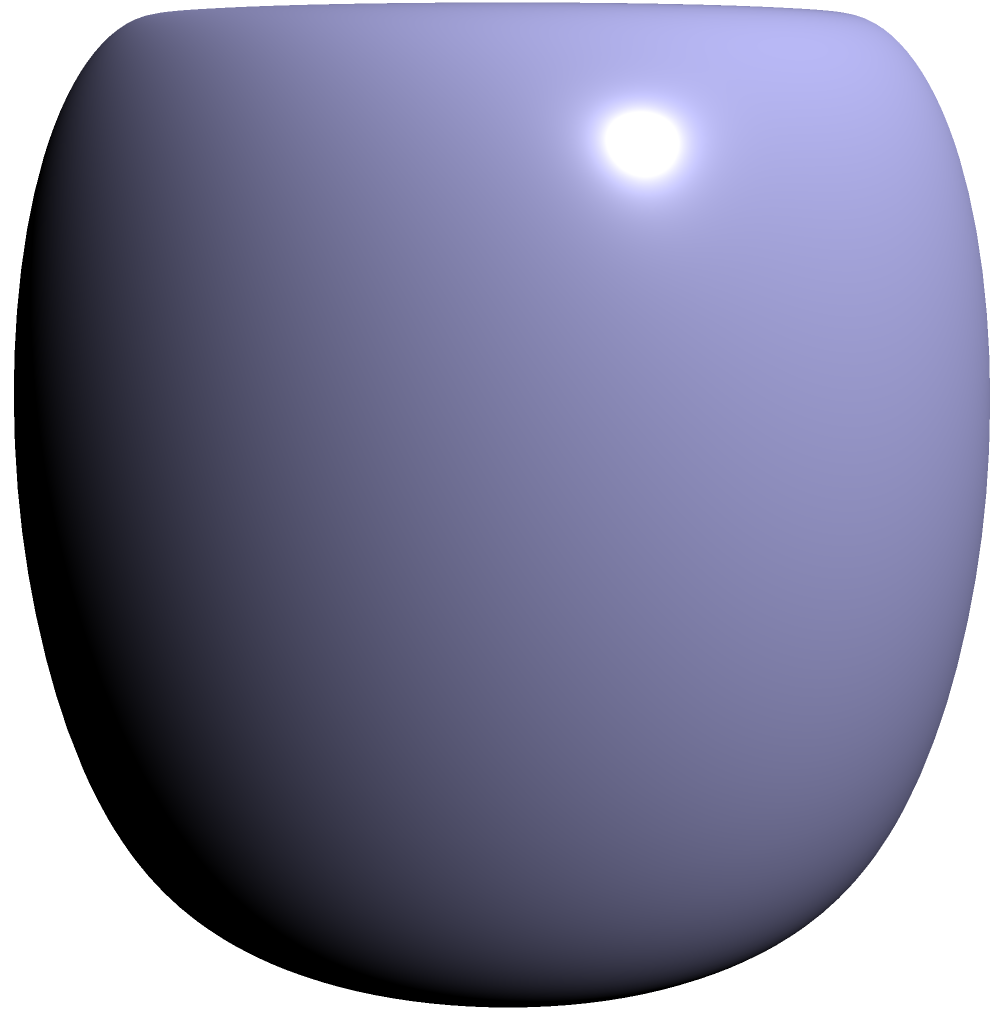Consider a compact surface $\Sigma$ without boundary, as shown in the figure. If the Gaussian curvature $K$ of $\Sigma$ is given by $K(x,y,z) = \frac{1}{(2+\cos z)^2}$, and the surface area of $\Sigma$ is $8\pi^2$, what is the Euler characteristic $\chi(\Sigma)$ of the surface? To solve this problem, we'll use the Gauss-Bonnet theorem, which relates the Gaussian curvature of a surface to its Euler characteristic. The steps are as follows:

1) The Gauss-Bonnet theorem states that for a compact surface $\Sigma$ without boundary:

   $$\int_\Sigma K dA = 2\pi\chi(\Sigma)$$

   where $K$ is the Gaussian curvature, $dA$ is the area element, and $\chi(\Sigma)$ is the Euler characteristic.

2) We're given that $K(x,y,z) = \frac{1}{(2+\cos z)^2}$ and the surface area is $8\pi^2$.

3) To find $\chi(\Sigma)$, we need to evaluate the integral:

   $$\int_\Sigma K dA = \int_\Sigma \frac{1}{(2+\cos z)^2} dA$$

4) Given the symmetry of the surface and the form of $K$, we can deduce that:

   $$\int_\Sigma \frac{1}{(2+\cos z)^2} dA = \frac{1}{4} \cdot 8\pi^2 = 2\pi^2$$

   This is because the average value of $\frac{1}{(2+\cos z)^2}$ over the surface is $\frac{1}{4}$.

5) Now we can equate this to the right side of the Gauss-Bonnet theorem:

   $$2\pi^2 = 2\pi\chi(\Sigma)$$

6) Solving for $\chi(\Sigma)$:

   $$\chi(\Sigma) = \frac{2\pi^2}{2\pi} = \pi$$

Therefore, the Euler characteristic of the surface $\Sigma$ is $\pi$.
Answer: $\pi$ 